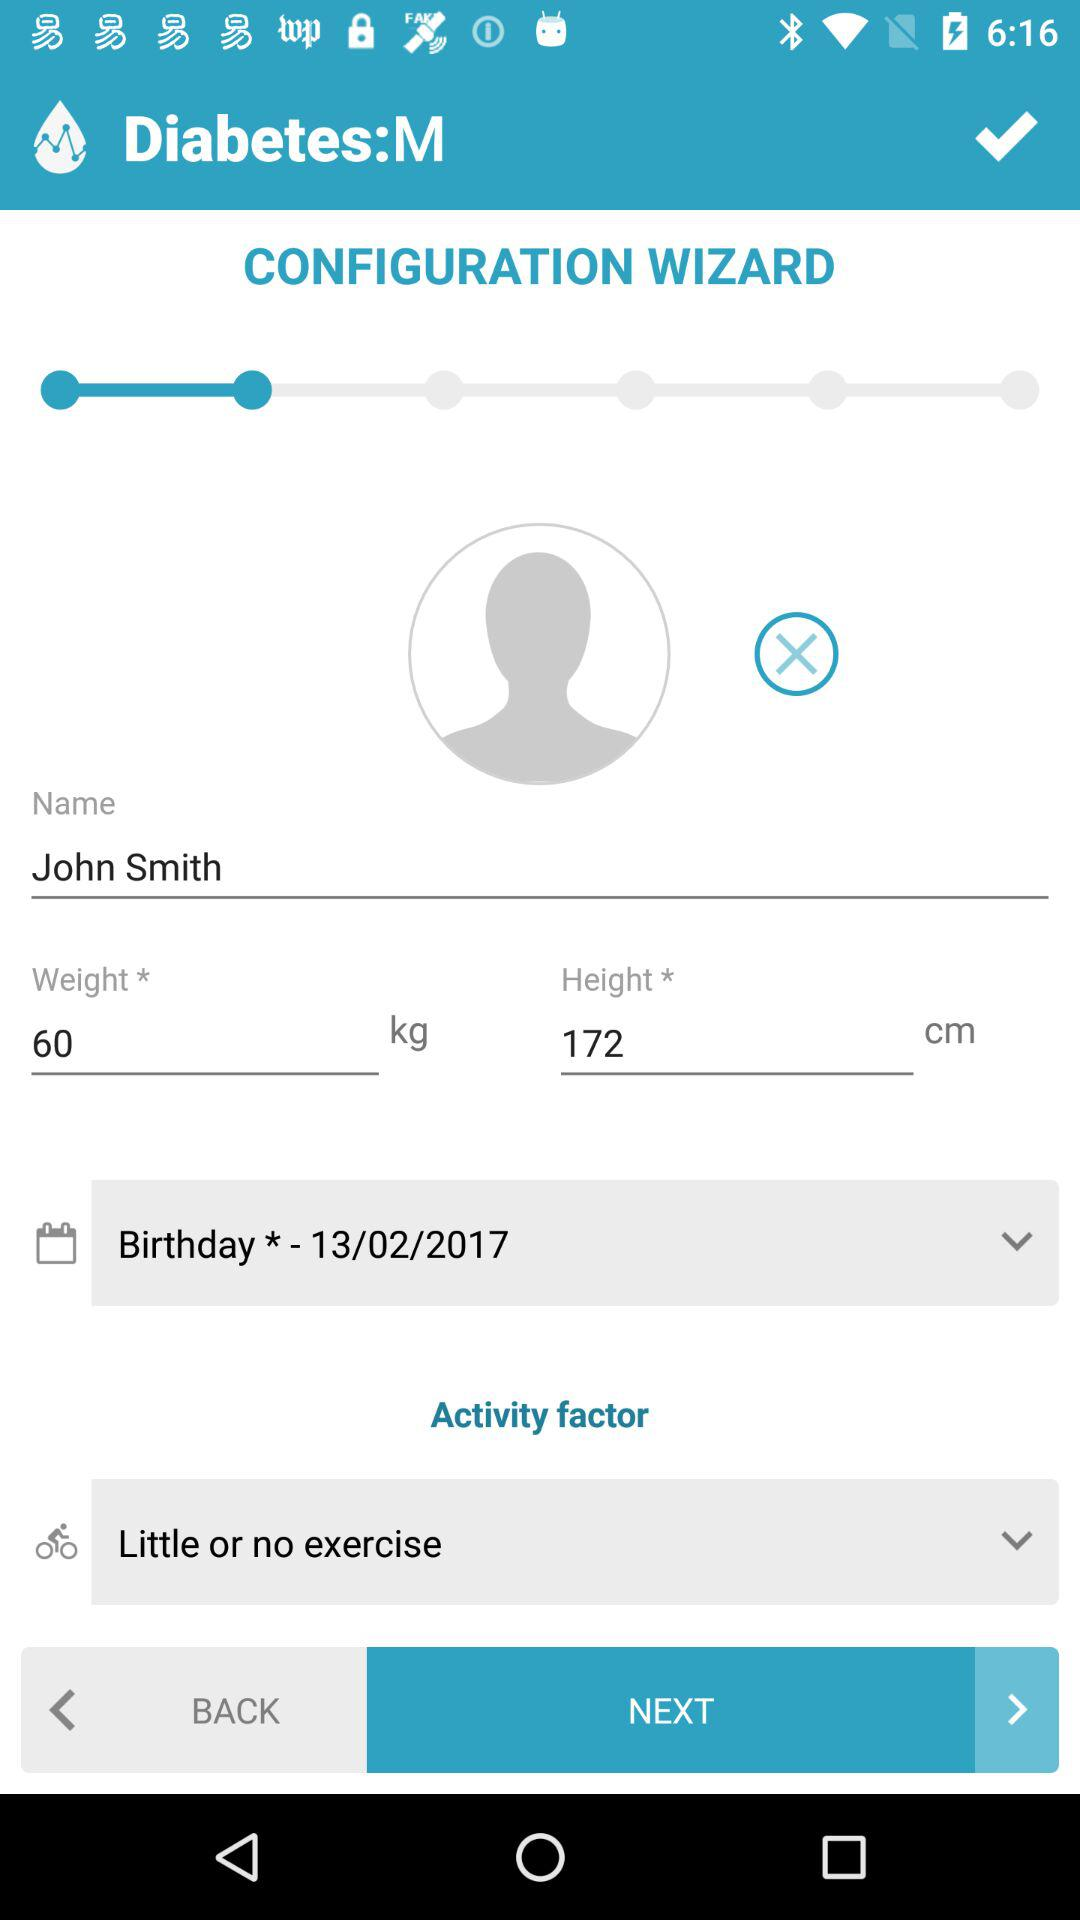What is the weight? The weight is 60 kg. 